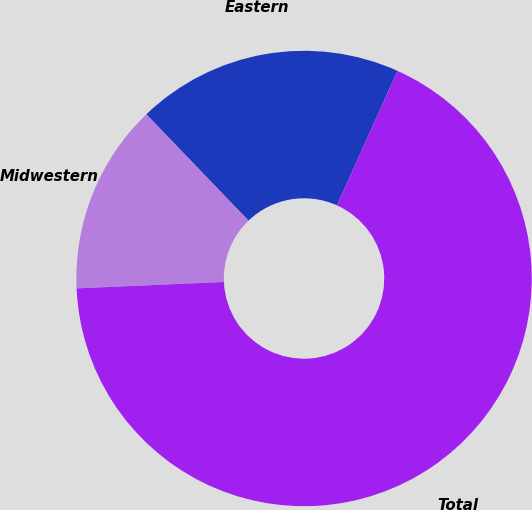Convert chart. <chart><loc_0><loc_0><loc_500><loc_500><pie_chart><fcel>Eastern<fcel>Midwestern<fcel>Total<nl><fcel>18.91%<fcel>13.51%<fcel>67.58%<nl></chart> 